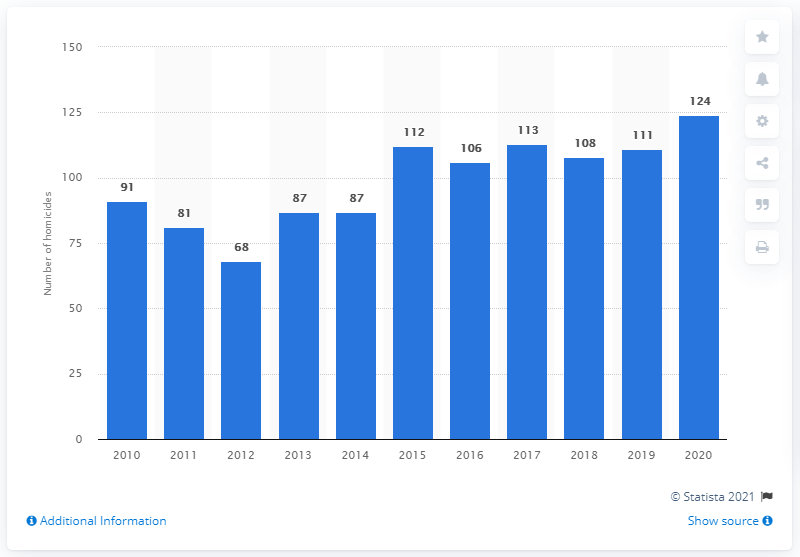Highlight a few significant elements in this photo. In 2012, a total of 68 homicides were confirmed. There were 124 confirmed homicides in Sweden in 2020. 